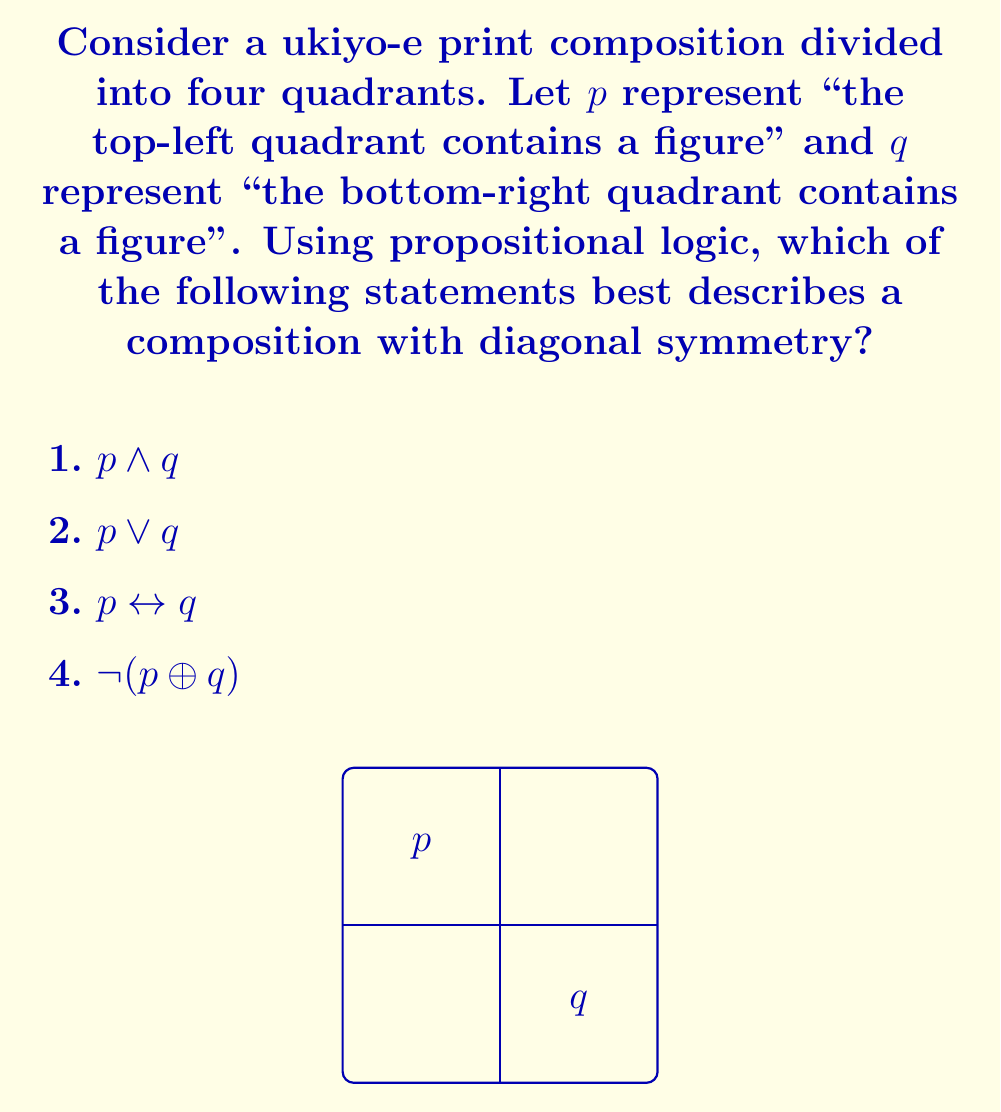What is the answer to this math problem? Let's analyze each option step-by-step:

1) $p \land q$: This means both the top-left and bottom-right quadrants contain figures. While this could be part of a diagonally symmetric composition, it doesn't necessarily guarantee symmetry.

2) $p \lor q$: This means either the top-left or bottom-right quadrant (or both) contains a figure. This is too broad and doesn't imply symmetry.

3) $p \leftrightarrow q$: This is a biconditional statement meaning "p if and only if q". In other words, the top-left quadrant contains a figure if and only if the bottom-right quadrant contains a figure. This perfectly describes diagonal symmetry.

4) $\neg(p \oplus q)$: This is the negation of the exclusive OR. It means either both p and q are true, or both are false. While this could describe diagonal symmetry, it's not as precise as option 3.

In ukiyo-e printmaking, balance and symmetry are crucial elements of composition. Diagonal symmetry, where elements in opposite corners mirror each other, is a common technique to achieve visual balance. The statement $p \leftrightarrow q$ captures this concept most accurately, as it ensures that the presence (or absence) of a figure in one corner is always matched in the opposite corner.
Answer: 3) $p \leftrightarrow q$ 